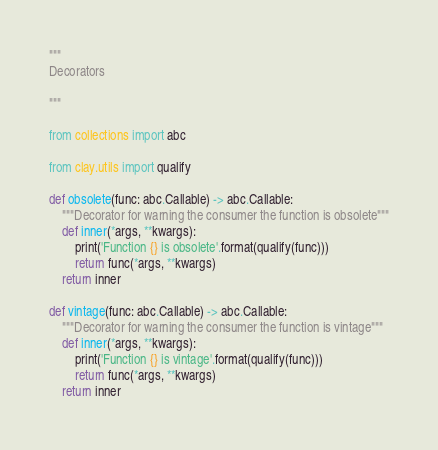<code> <loc_0><loc_0><loc_500><loc_500><_Python_>
"""
Decorators

"""

from collections import abc

from clay.utils import qualify

def obsolete(func: abc.Callable) -> abc.Callable:
    """Decorator for warning the consumer the function is obsolete"""
    def inner(*args, **kwargs):
        print('Function {} is obsolete'.format(qualify(func)))
        return func(*args, **kwargs)
    return inner

def vintage(func: abc.Callable) -> abc.Callable:
    """Decorator for warning the consumer the function is vintage"""
    def inner(*args, **kwargs):
        print('Function {} is vintage'.format(qualify(func)))
        return func(*args, **kwargs)
    return inner
</code> 